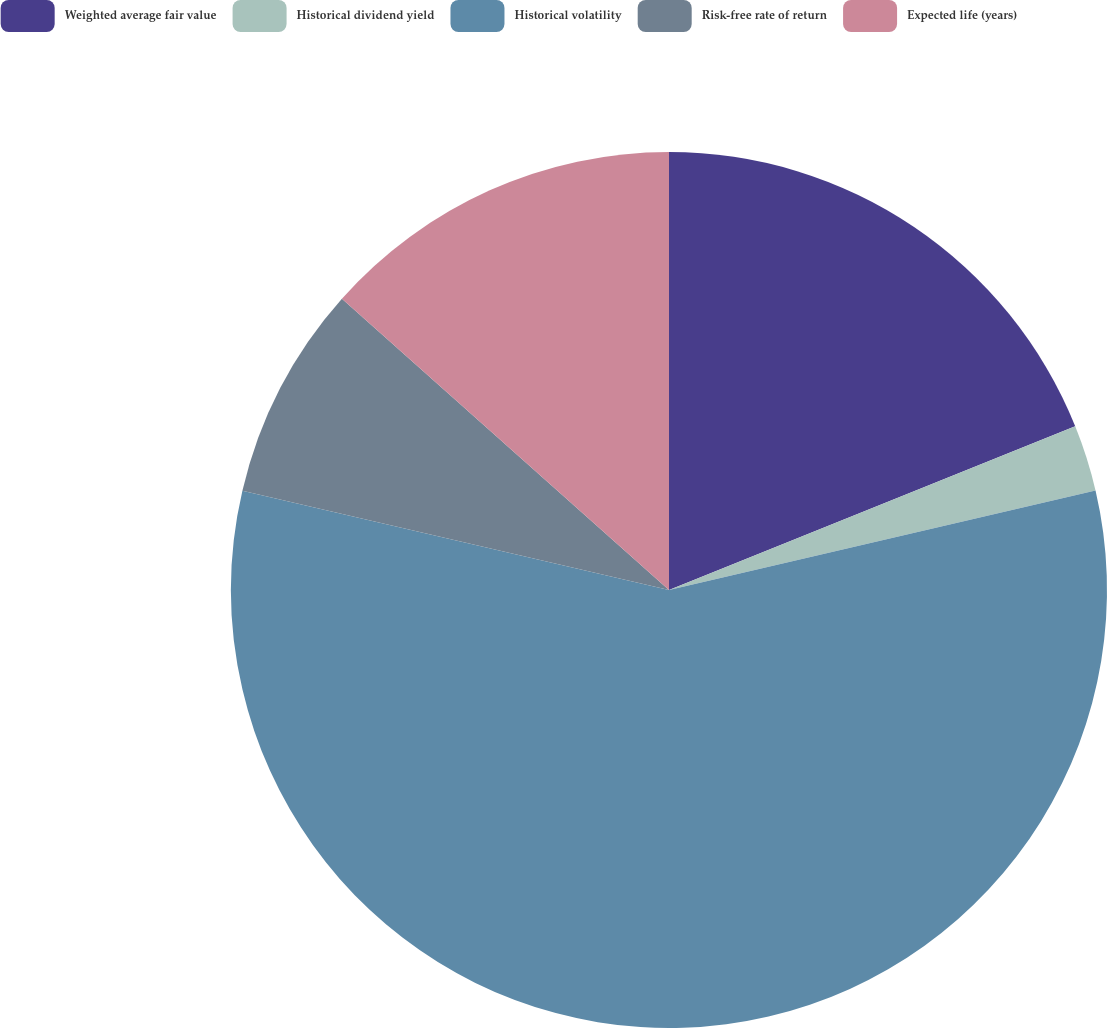<chart> <loc_0><loc_0><loc_500><loc_500><pie_chart><fcel>Weighted average fair value<fcel>Historical dividend yield<fcel>Historical volatility<fcel>Risk-free rate of return<fcel>Expected life (years)<nl><fcel>18.9%<fcel>2.45%<fcel>57.29%<fcel>7.94%<fcel>13.42%<nl></chart> 